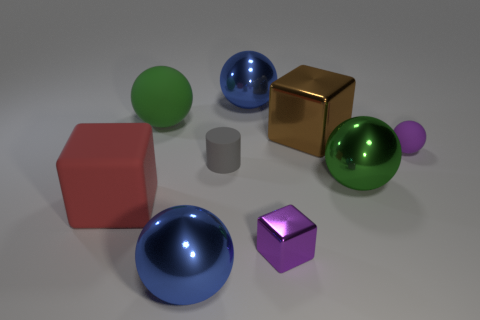Can you describe the different materials of the objects displayed? Certainly! In the image, there are objects with various materials: some possess a metallic sheen, reflecting light with a glossy finish; others are matte, diffusing the light softly. The metallic ones sparkle with reflections, while the matte surfaces absorb the light, providing a more subdued visual texture. 